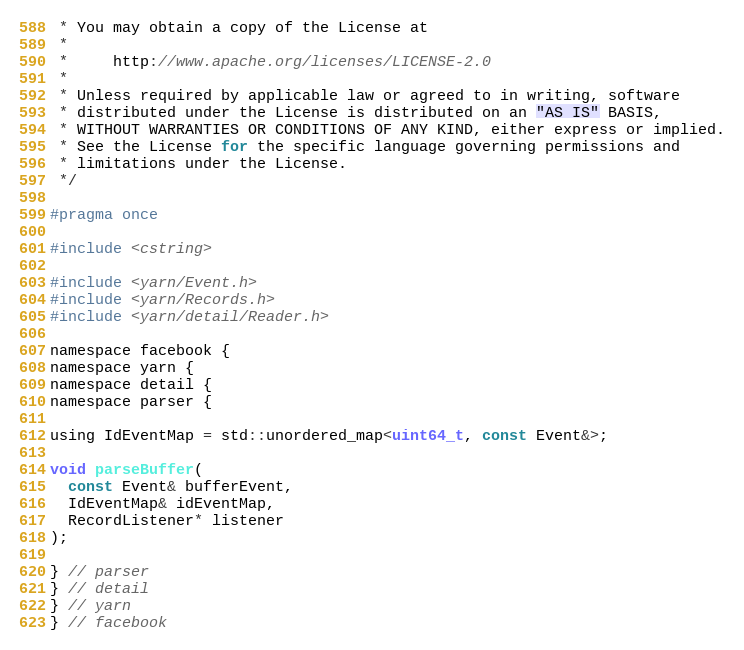Convert code to text. <code><loc_0><loc_0><loc_500><loc_500><_C_> * You may obtain a copy of the License at
 *
 *     http://www.apache.org/licenses/LICENSE-2.0
 *
 * Unless required by applicable law or agreed to in writing, software
 * distributed under the License is distributed on an "AS IS" BASIS,
 * WITHOUT WARRANTIES OR CONDITIONS OF ANY KIND, either express or implied.
 * See the License for the specific language governing permissions and
 * limitations under the License.
 */

#pragma once

#include <cstring>

#include <yarn/Event.h>
#include <yarn/Records.h>
#include <yarn/detail/Reader.h>

namespace facebook {
namespace yarn {
namespace detail {
namespace parser {

using IdEventMap = std::unordered_map<uint64_t, const Event&>;

void parseBuffer(
  const Event& bufferEvent, 
  IdEventMap& idEventMap,
  RecordListener* listener
);

} // parser
} // detail
} // yarn
} // facebook
</code> 